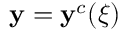<formula> <loc_0><loc_0><loc_500><loc_500>y = y ^ { c } ( \xi )</formula> 